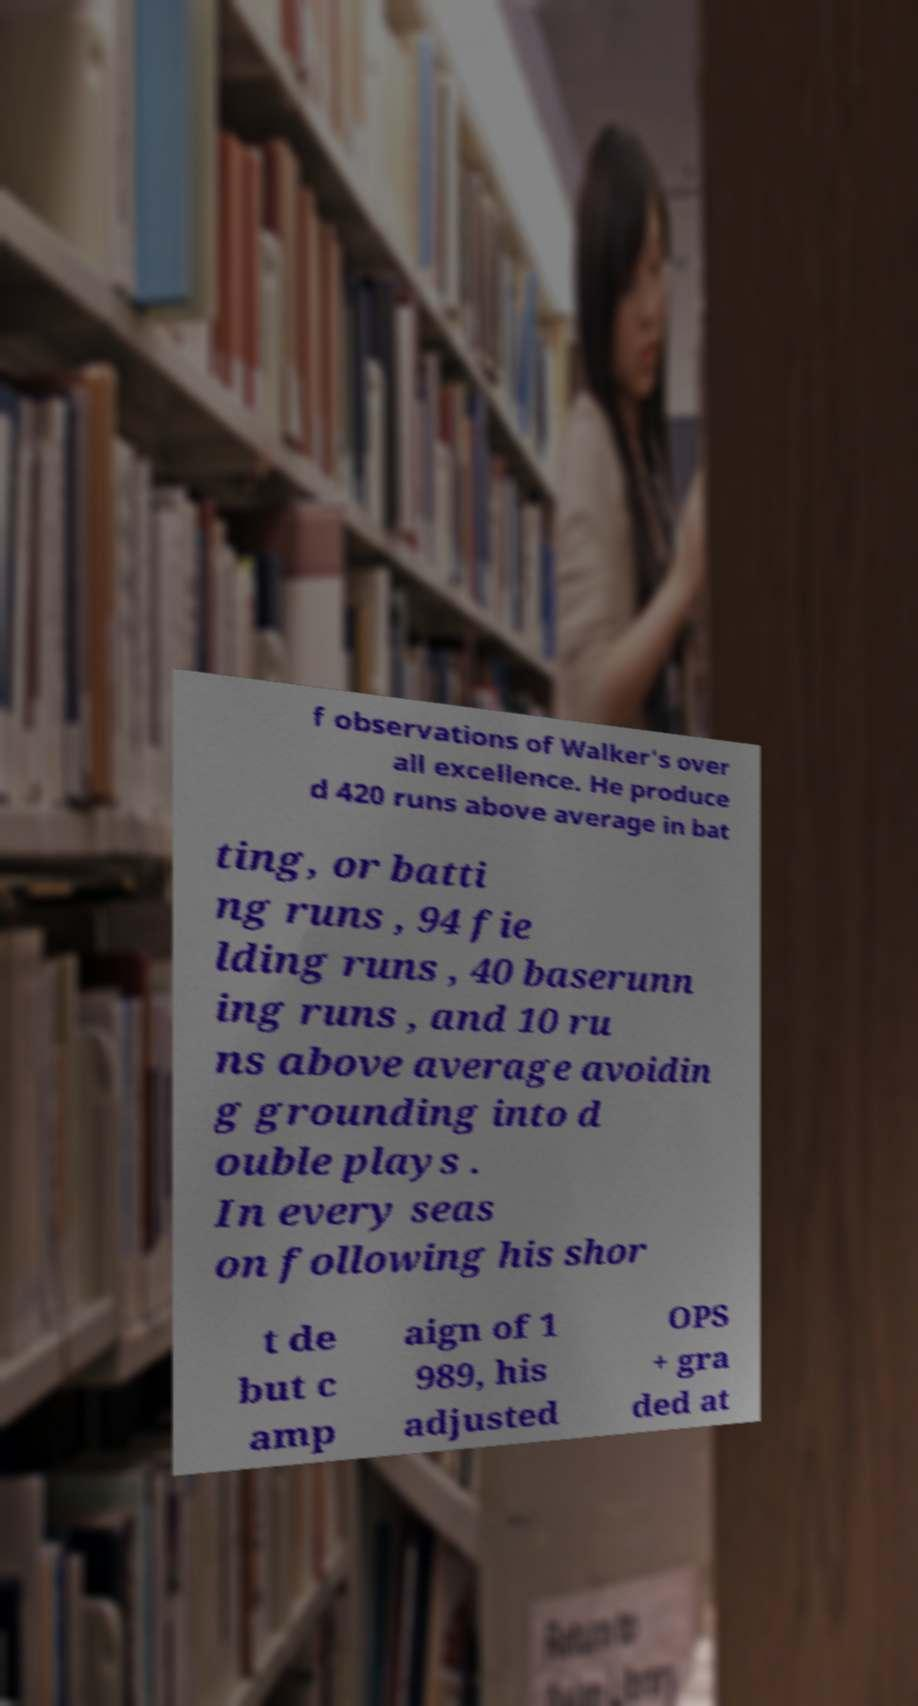Could you assist in decoding the text presented in this image and type it out clearly? f observations of Walker's over all excellence. He produce d 420 runs above average in bat ting, or batti ng runs , 94 fie lding runs , 40 baserunn ing runs , and 10 ru ns above average avoidin g grounding into d ouble plays . In every seas on following his shor t de but c amp aign of 1 989, his adjusted OPS + gra ded at 